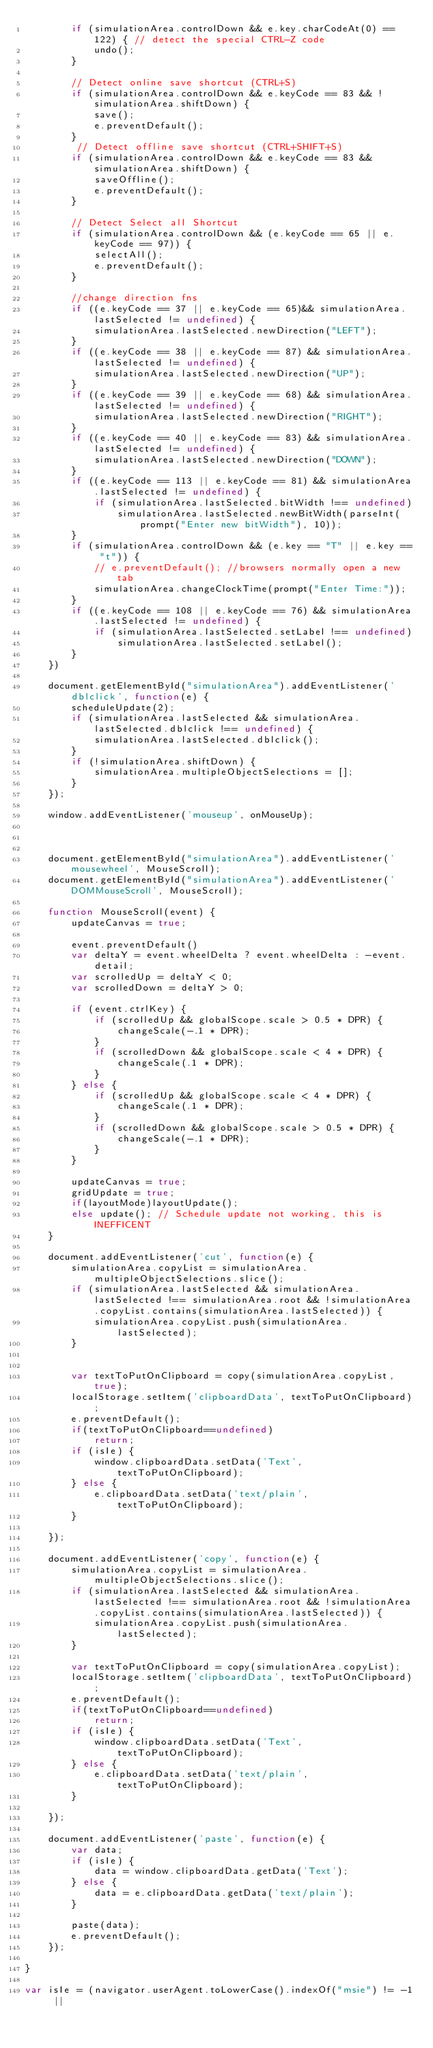Convert code to text. <code><loc_0><loc_0><loc_500><loc_500><_JavaScript_>        if (simulationArea.controlDown && e.key.charCodeAt(0) == 122) { // detect the special CTRL-Z code
            undo();
        }

        // Detect online save shortcut (CTRL+S)
        if (simulationArea.controlDown && e.keyCode == 83 && !simulationArea.shiftDown) {
            save();
            e.preventDefault();
        }
         // Detect offline save shortcut (CTRL+SHIFT+S)
        if (simulationArea.controlDown && e.keyCode == 83 && simulationArea.shiftDown) {
            saveOffline();
            e.preventDefault();
        }

        // Detect Select all Shortcut
        if (simulationArea.controlDown && (e.keyCode == 65 || e.keyCode == 97)) {
            selectAll();
            e.preventDefault();
        }

        //change direction fns
        if ((e.keyCode == 37 || e.keyCode == 65)&& simulationArea.lastSelected != undefined) {
            simulationArea.lastSelected.newDirection("LEFT");
        }
        if ((e.keyCode == 38 || e.keyCode == 87) && simulationArea.lastSelected != undefined) {
            simulationArea.lastSelected.newDirection("UP");
        }
        if ((e.keyCode == 39 || e.keyCode == 68) && simulationArea.lastSelected != undefined) {
            simulationArea.lastSelected.newDirection("RIGHT");
        }
        if ((e.keyCode == 40 || e.keyCode == 83) && simulationArea.lastSelected != undefined) {
            simulationArea.lastSelected.newDirection("DOWN");
        }
        if ((e.keyCode == 113 || e.keyCode == 81) && simulationArea.lastSelected != undefined) {
            if (simulationArea.lastSelected.bitWidth !== undefined)
                simulationArea.lastSelected.newBitWidth(parseInt(prompt("Enter new bitWidth"), 10));
        }
        if (simulationArea.controlDown && (e.key == "T" || e.key == "t")) {
            // e.preventDefault(); //browsers normally open a new tab
            simulationArea.changeClockTime(prompt("Enter Time:"));
        }
        if ((e.keyCode == 108 || e.keyCode == 76) && simulationArea.lastSelected != undefined) {
            if (simulationArea.lastSelected.setLabel !== undefined)
                simulationArea.lastSelected.setLabel();
        }
    })

    document.getElementById("simulationArea").addEventListener('dblclick', function(e) {
        scheduleUpdate(2);
        if (simulationArea.lastSelected && simulationArea.lastSelected.dblclick !== undefined) {
            simulationArea.lastSelected.dblclick();
        }
        if (!simulationArea.shiftDown) {
            simulationArea.multipleObjectSelections = [];
        }
    });

    window.addEventListener('mouseup', onMouseUp);



    document.getElementById("simulationArea").addEventListener('mousewheel', MouseScroll);
    document.getElementById("simulationArea").addEventListener('DOMMouseScroll', MouseScroll);

    function MouseScroll(event) {
        updateCanvas = true;

        event.preventDefault()
        var deltaY = event.wheelDelta ? event.wheelDelta : -event.detail;
        var scrolledUp = deltaY < 0;
        var scrolledDown = deltaY > 0;

        if (event.ctrlKey) {
            if (scrolledUp && globalScope.scale > 0.5 * DPR) {
                changeScale(-.1 * DPR);
            }
            if (scrolledDown && globalScope.scale < 4 * DPR) {
                changeScale(.1 * DPR);
            }
        } else {
            if (scrolledUp && globalScope.scale < 4 * DPR) {
                changeScale(.1 * DPR);
            }
            if (scrolledDown && globalScope.scale > 0.5 * DPR) {
                changeScale(-.1 * DPR);
            }
        }

        updateCanvas = true;
        gridUpdate = true;
        if(layoutMode)layoutUpdate();
        else update(); // Schedule update not working, this is INEFFICENT
    }

    document.addEventListener('cut', function(e) {
        simulationArea.copyList = simulationArea.multipleObjectSelections.slice();
        if (simulationArea.lastSelected && simulationArea.lastSelected !== simulationArea.root && !simulationArea.copyList.contains(simulationArea.lastSelected)) {
            simulationArea.copyList.push(simulationArea.lastSelected);
        }


        var textToPutOnClipboard = copy(simulationArea.copyList, true);
        localStorage.setItem('clipboardData', textToPutOnClipboard);
        e.preventDefault();
        if(textToPutOnClipboard==undefined)
            return;
        if (isIe) {
            window.clipboardData.setData('Text', textToPutOnClipboard);
        } else {
            e.clipboardData.setData('text/plain', textToPutOnClipboard);
        }

    });

    document.addEventListener('copy', function(e) {
        simulationArea.copyList = simulationArea.multipleObjectSelections.slice();
        if (simulationArea.lastSelected && simulationArea.lastSelected !== simulationArea.root && !simulationArea.copyList.contains(simulationArea.lastSelected)) {
            simulationArea.copyList.push(simulationArea.lastSelected);
        }

        var textToPutOnClipboard = copy(simulationArea.copyList);
        localStorage.setItem('clipboardData', textToPutOnClipboard);
        e.preventDefault();
        if(textToPutOnClipboard==undefined)
            return;
        if (isIe) {
            window.clipboardData.setData('Text', textToPutOnClipboard);
        } else {
            e.clipboardData.setData('text/plain', textToPutOnClipboard);
        }

    });

    document.addEventListener('paste', function(e) {
        var data;
        if (isIe) {
            data = window.clipboardData.getData('Text');
        } else {
            data = e.clipboardData.getData('text/plain');
        }

        paste(data);
        e.preventDefault();
    });

}

var isIe = (navigator.userAgent.toLowerCase().indexOf("msie") != -1 ||</code> 